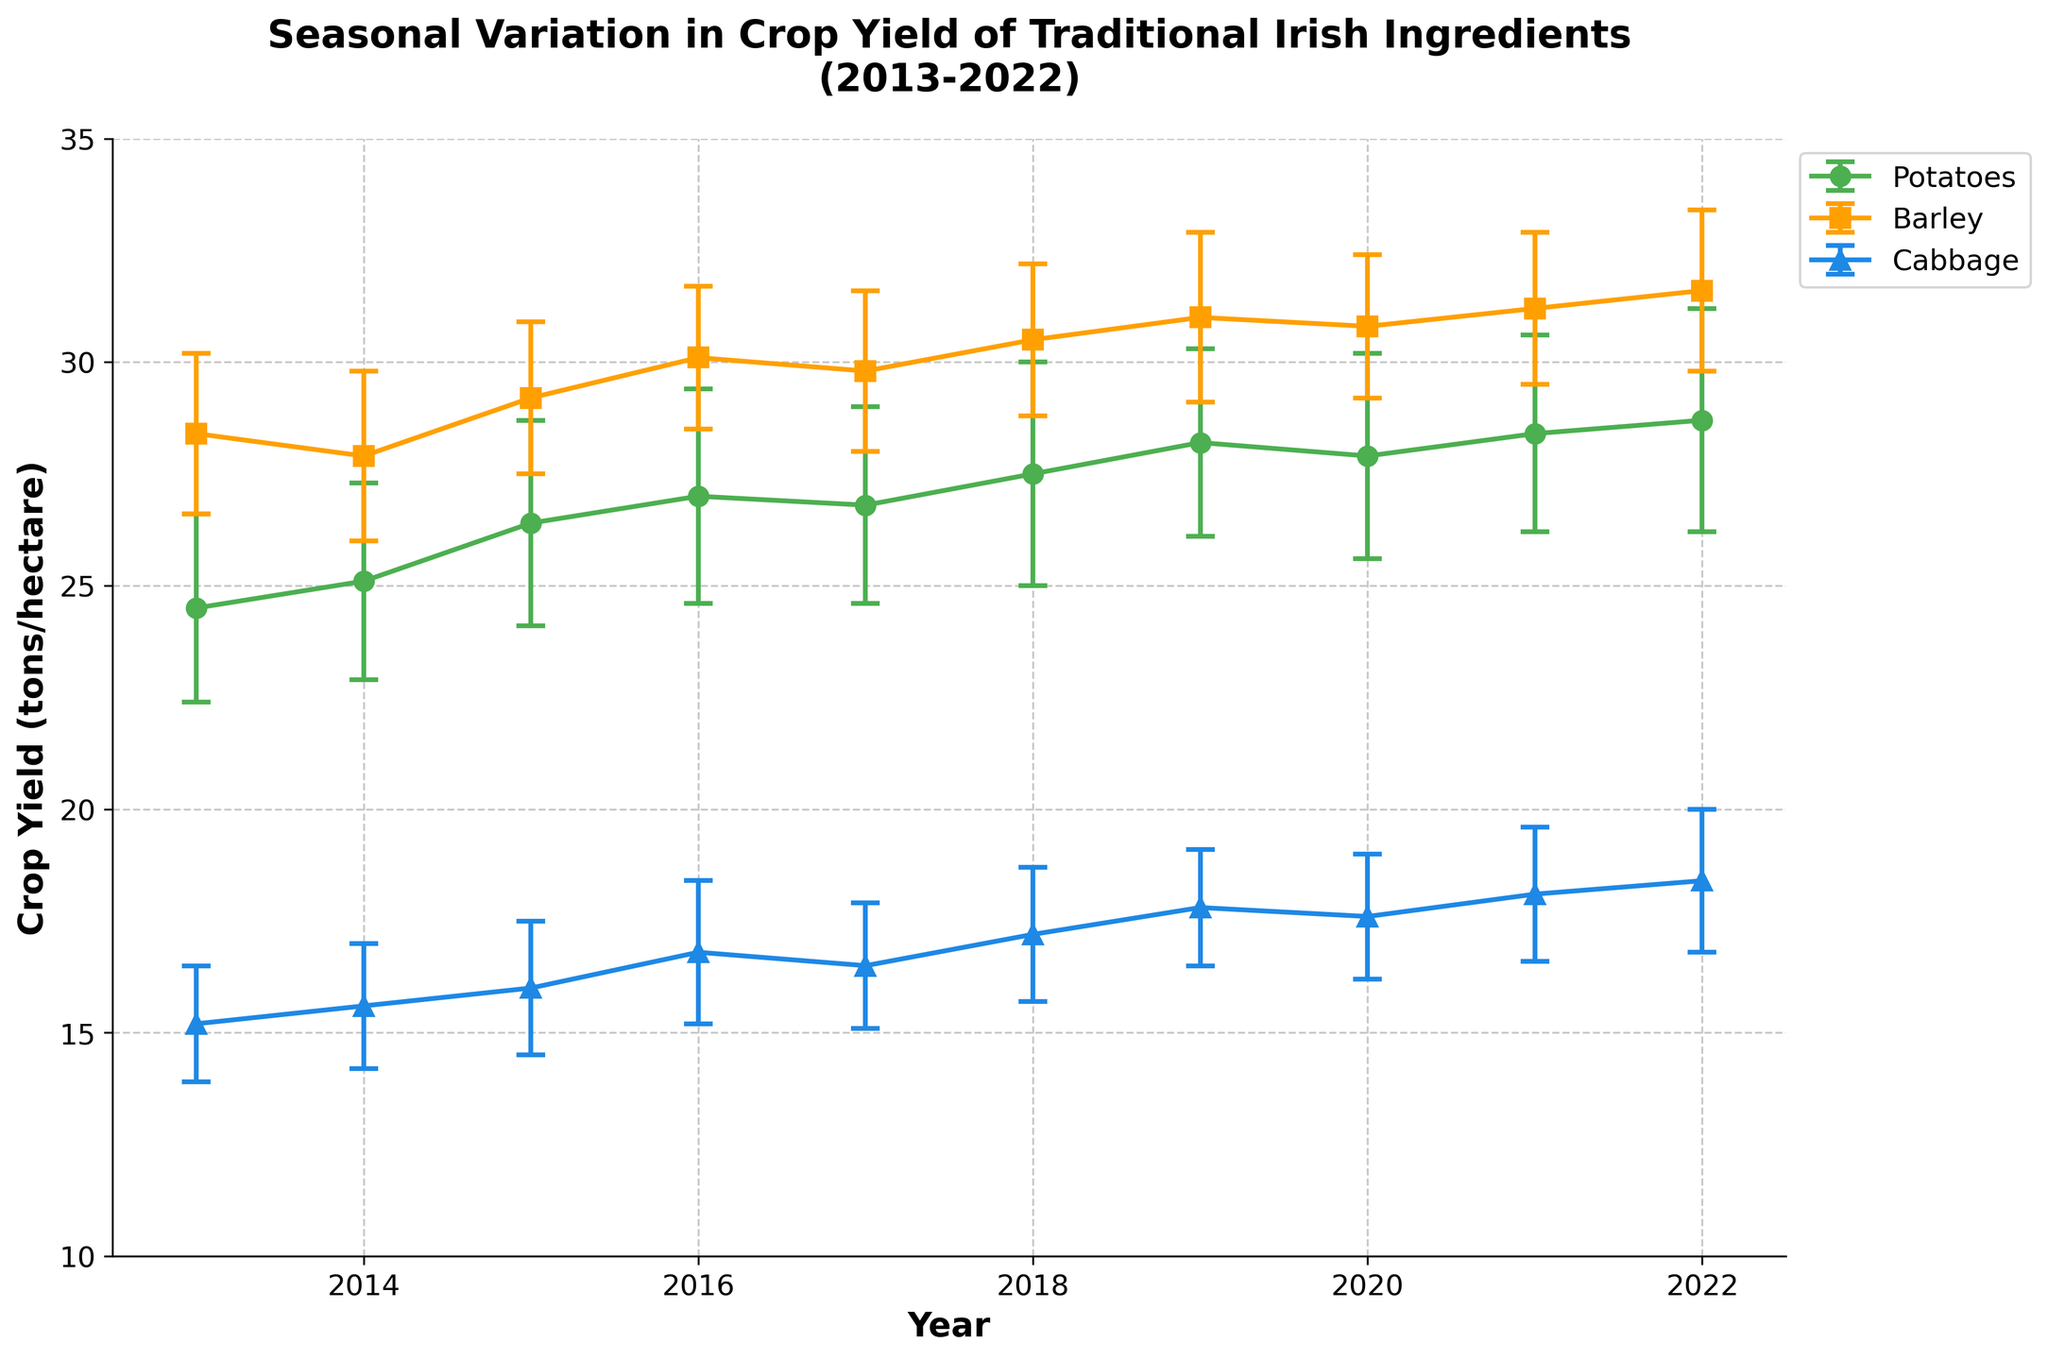What is the range of years displayed in the plot? The x-axis of the plot lists years ranging from the start to the end of the displayed time frame. The first visible year is 2013 and the last visible year is 2022.
Answer: 2013-2022 What is the crop with the highest average yield in 2022? By looking at the 2022 data points and comparing the average yields of each crop, Barley has the highest average yield since its error bar is the highest in 2022.
Answer: Barley Which ingredient showed the most overall increase in yield from 2013 to 2022? For each ingredient, calculate the difference in mean yield from 2013 to 2022. Potatoes went from 24.5 to 28.7, Barley from 28.4 to 31.6, and Cabbage from 15.2 to 18.4. Barley's increase is the largest at 3.2 tons/hectare.
Answer: Barley In which year did Potatoes have the highest crop yield? Identify the data points corresponding to Potatoes and compare their values across the years. The highest yield for Potatoes occurred in 2022 with a value of 28.7.
Answer: 2022 What is the average crop yield of Cabbage in 2017? Locate the 2017 data point for Cabbage and read its average yield, which is 16.5 tons/hectare.
Answer: 16.5 How does the crop yield of Barley in 2016 compare to that in 2018? Locate the data points for Barley in 2016 and 2018. In 2016, the average yield is 30.1, and in 2018, it is 30.5. Therefore, the yield increased from 2016 to 2018.
Answer: 2018 is higher Which year had the largest variety in crop yield among the three ingredients? Compare the range of crop yields (difference between the highest and lowest yield) for each year. The year with the largest range between the crop with the highest mean yield and the crop with the lowest is 2022 (31.6 for Barley - 18.4 for Cabbage = 13.2).
Answer: 2022 What is the error margin for Cabbage in 2019? The error margin is indicated by the error bar. For Cabbage, it reflects the standard deviation listed as 1.3.
Answer: 1.3 